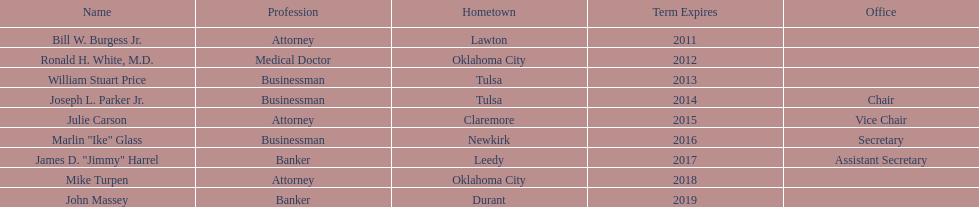Who can be identified as regents? Bill W. Burgess Jr., Ronald H. White, M.D., William Stuart Price, Joseph L. Parker Jr., Julie Carson, Marlin "Ike" Glass, James D. "Jimmy" Harrel, Mike Turpen, John Massey. Among them, who has a background in business? William Stuart Price, Joseph L. Parker Jr., Marlin "Ike" Glass. From this group, who hails from tulsa? William Stuart Price, Joseph L. Parker Jr. Lastly, whose term came to an end in 2013? William Stuart Price. 